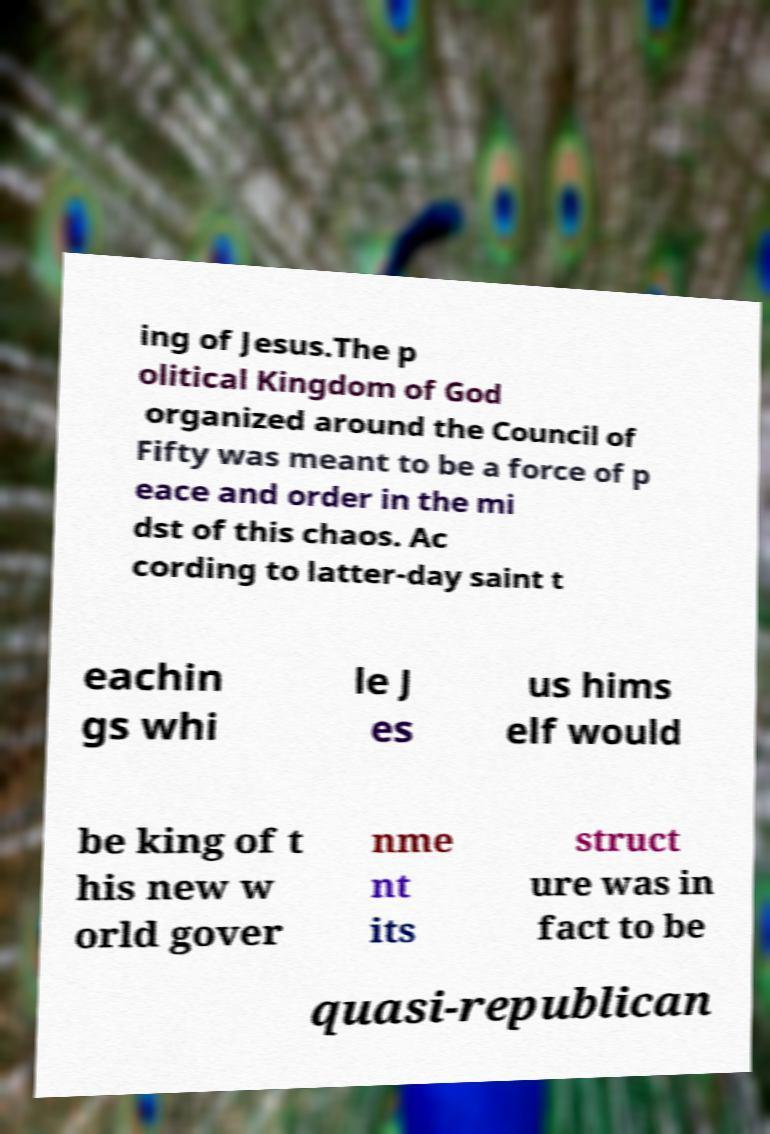Please read and relay the text visible in this image. What does it say? ing of Jesus.The p olitical Kingdom of God organized around the Council of Fifty was meant to be a force of p eace and order in the mi dst of this chaos. Ac cording to latter-day saint t eachin gs whi le J es us hims elf would be king of t his new w orld gover nme nt its struct ure was in fact to be quasi-republican 